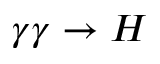<formula> <loc_0><loc_0><loc_500><loc_500>\gamma \gamma \rightarrow H</formula> 